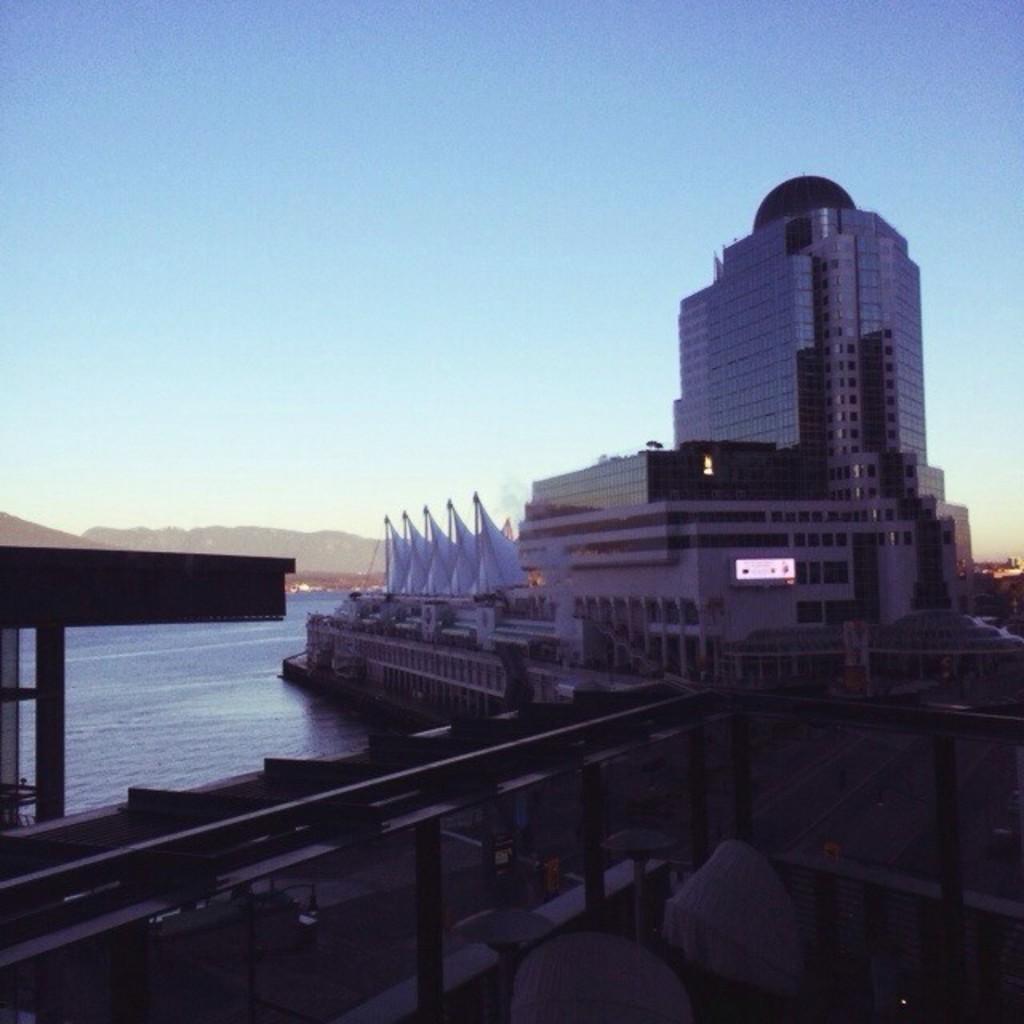Can you describe this image briefly? In this image I can see the ship on the water. In the background I can see few buildings and the sky is in blue and white color. 